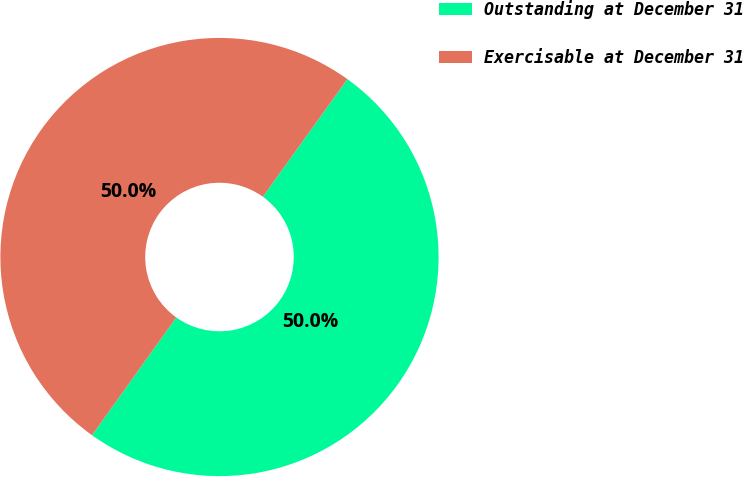<chart> <loc_0><loc_0><loc_500><loc_500><pie_chart><fcel>Outstanding at December 31<fcel>Exercisable at December 31<nl><fcel>49.96%<fcel>50.04%<nl></chart> 